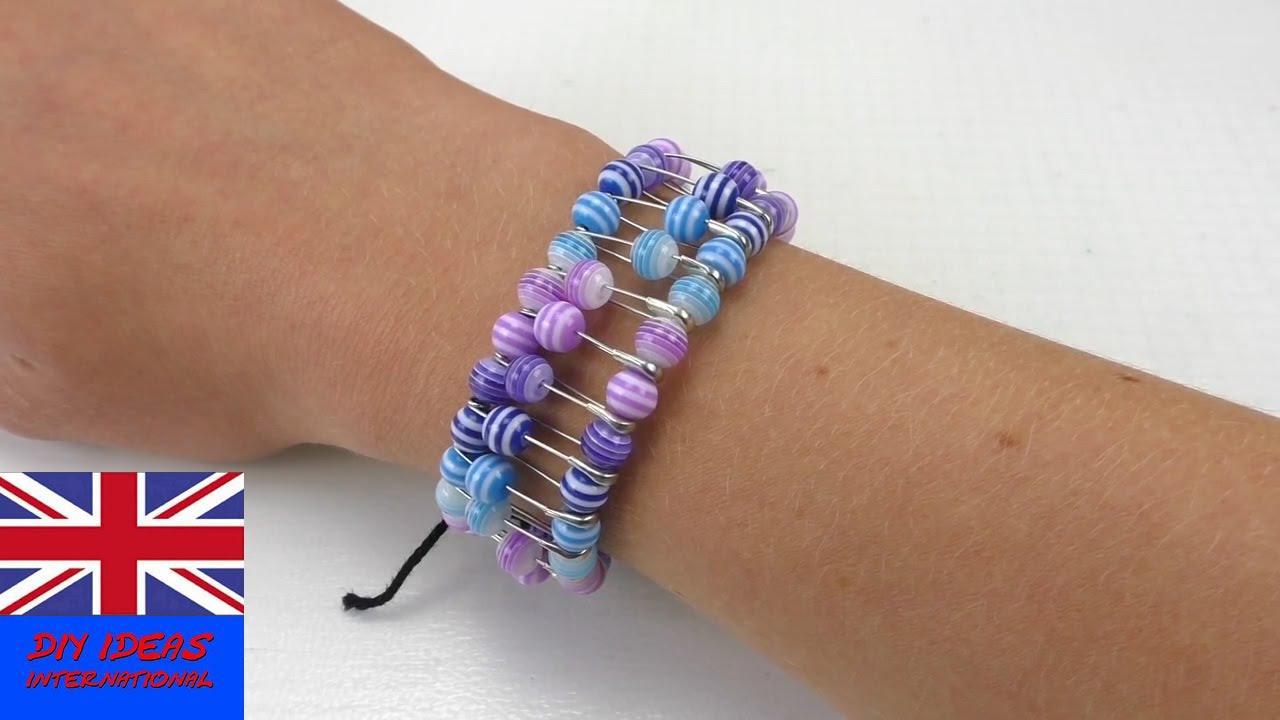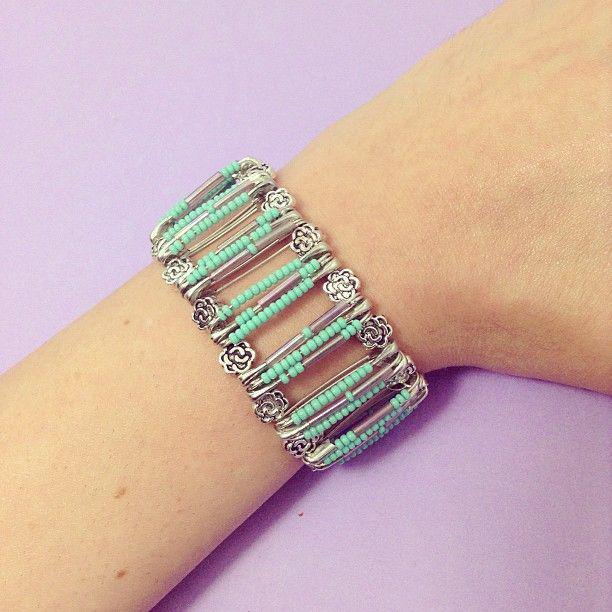The first image is the image on the left, the second image is the image on the right. Analyze the images presented: Is the assertion "The image on the right contains a bracelet with green beads on it." valid? Answer yes or no. Yes. The first image is the image on the left, the second image is the image on the right. Given the left and right images, does the statement "There are multiple pieces of jewelry on a woman’s arm that are not just gold colored." hold true? Answer yes or no. No. 